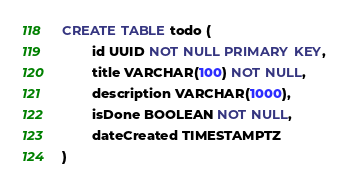<code> <loc_0><loc_0><loc_500><loc_500><_SQL_>CREATE TABLE todo (
        id UUID NOT NULL PRIMARY KEY,
        title VARCHAR(100) NOT NULL,
        description VARCHAR(1000),
        isDone BOOLEAN NOT NULL,
        dateCreated TIMESTAMPTZ
)</code> 